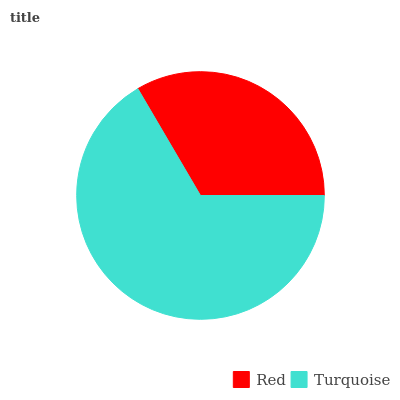Is Red the minimum?
Answer yes or no. Yes. Is Turquoise the maximum?
Answer yes or no. Yes. Is Turquoise the minimum?
Answer yes or no. No. Is Turquoise greater than Red?
Answer yes or no. Yes. Is Red less than Turquoise?
Answer yes or no. Yes. Is Red greater than Turquoise?
Answer yes or no. No. Is Turquoise less than Red?
Answer yes or no. No. Is Turquoise the high median?
Answer yes or no. Yes. Is Red the low median?
Answer yes or no. Yes. Is Red the high median?
Answer yes or no. No. Is Turquoise the low median?
Answer yes or no. No. 